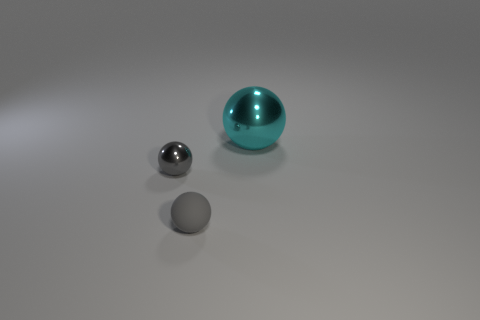Add 2 big metal spheres. How many objects exist? 5 Add 1 cyan shiny objects. How many cyan shiny objects are left? 2 Add 1 small objects. How many small objects exist? 3 Subtract 0 blue blocks. How many objects are left? 3 Subtract all gray metal things. Subtract all red rubber cylinders. How many objects are left? 2 